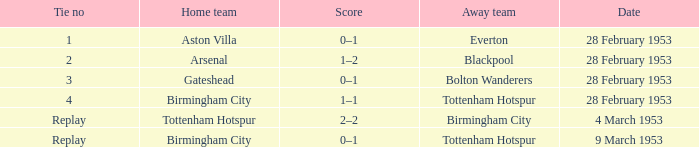Which Score has a Tie no of 1? 0–1. 